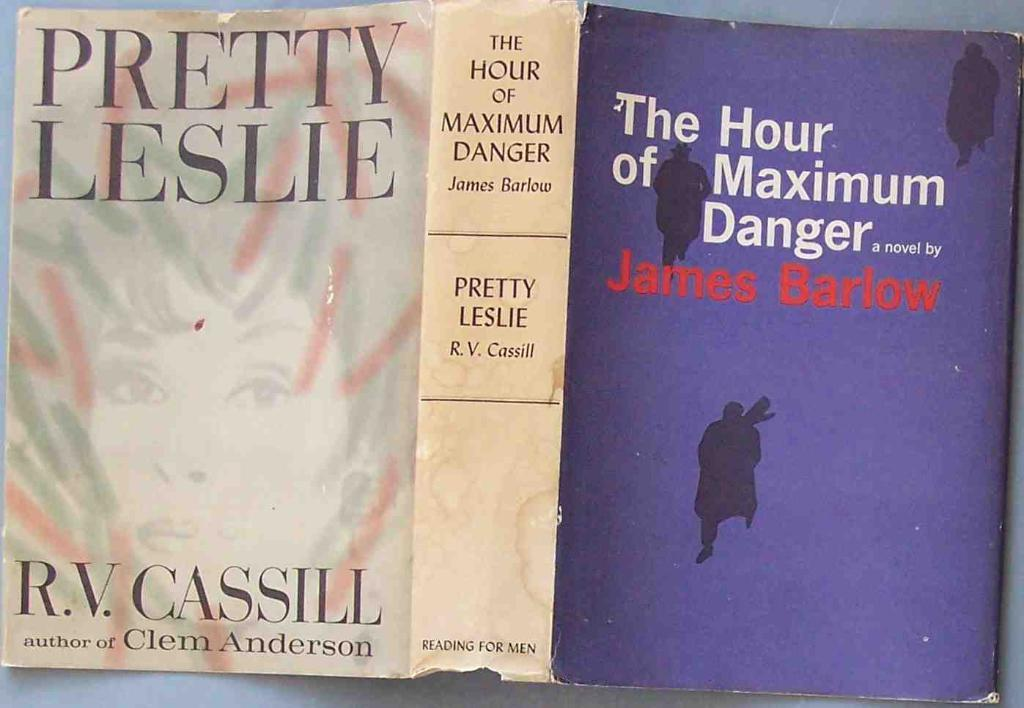Provide a one-sentence caption for the provided image. The dust jacket for the book Pretty Leslie by R.V. Cassill. 